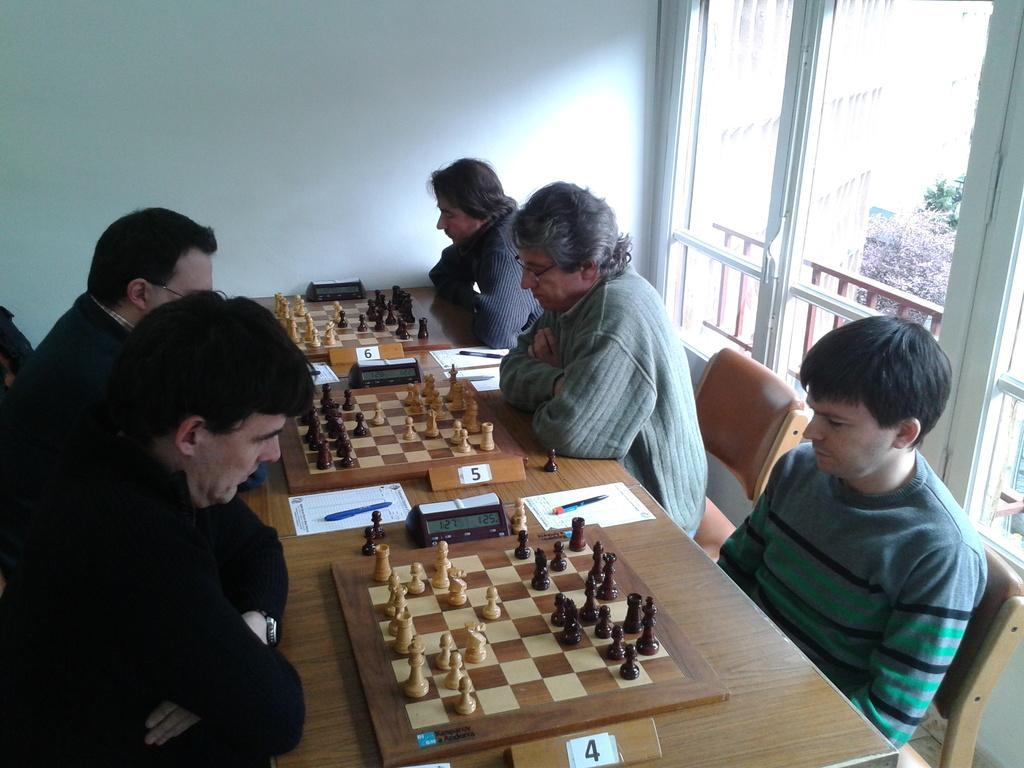Please provide a concise description of this image. In this picture we can see individual people sitting on their opposites and playing chess. There is also paper, pen and a timer clock in front of them. 